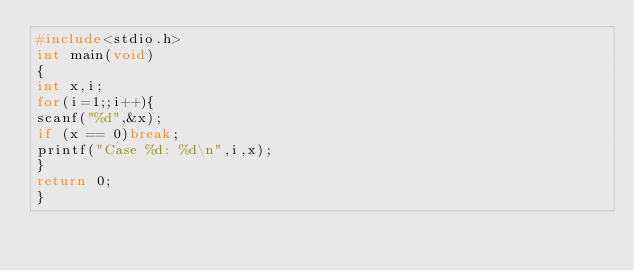<code> <loc_0><loc_0><loc_500><loc_500><_C_>#include<stdio.h>
int main(void)
{
int x,i;
for(i=1;;i++){
scanf("%d",&x);
if (x == 0)break;
printf("Case %d: %d\n",i,x);
}
return 0;
}</code> 